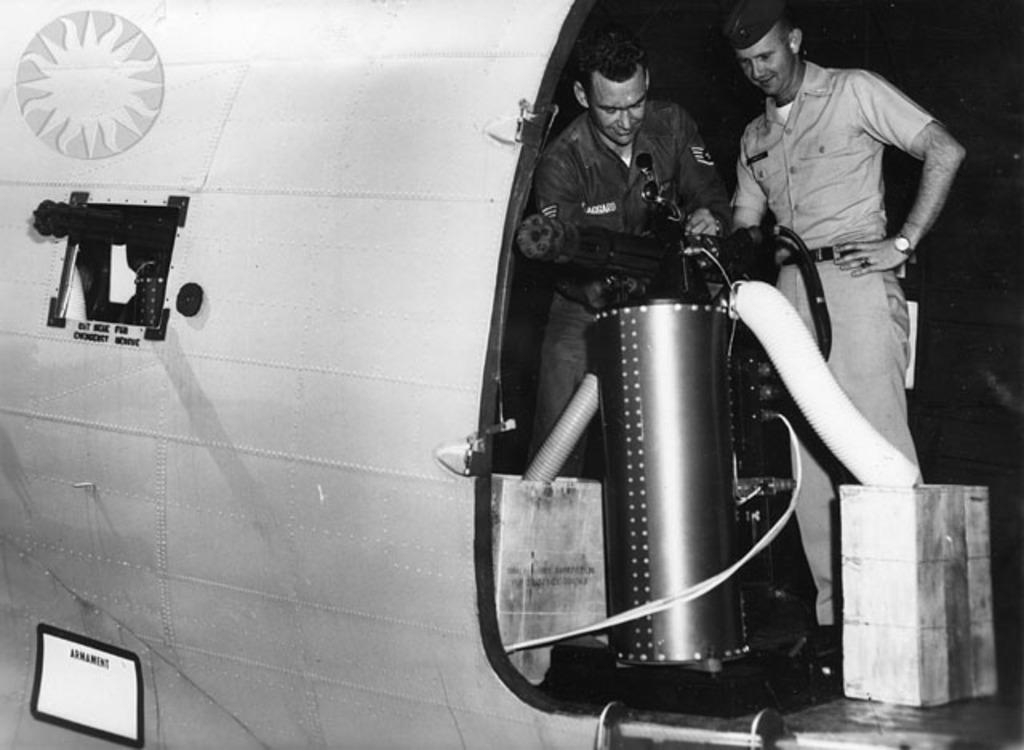How many people are in the aircraft in the image? There are two people in the aircraft in the image. What type of weapon can be seen in the image? There is a machine gun in the image. What other objects are present in the image besides the people and the machine gun? There are pipes and a container in the image. What type of flame can be seen coming from the machine gun in the image? There is no flame coming from the machine gun in the image; it is a static object. 